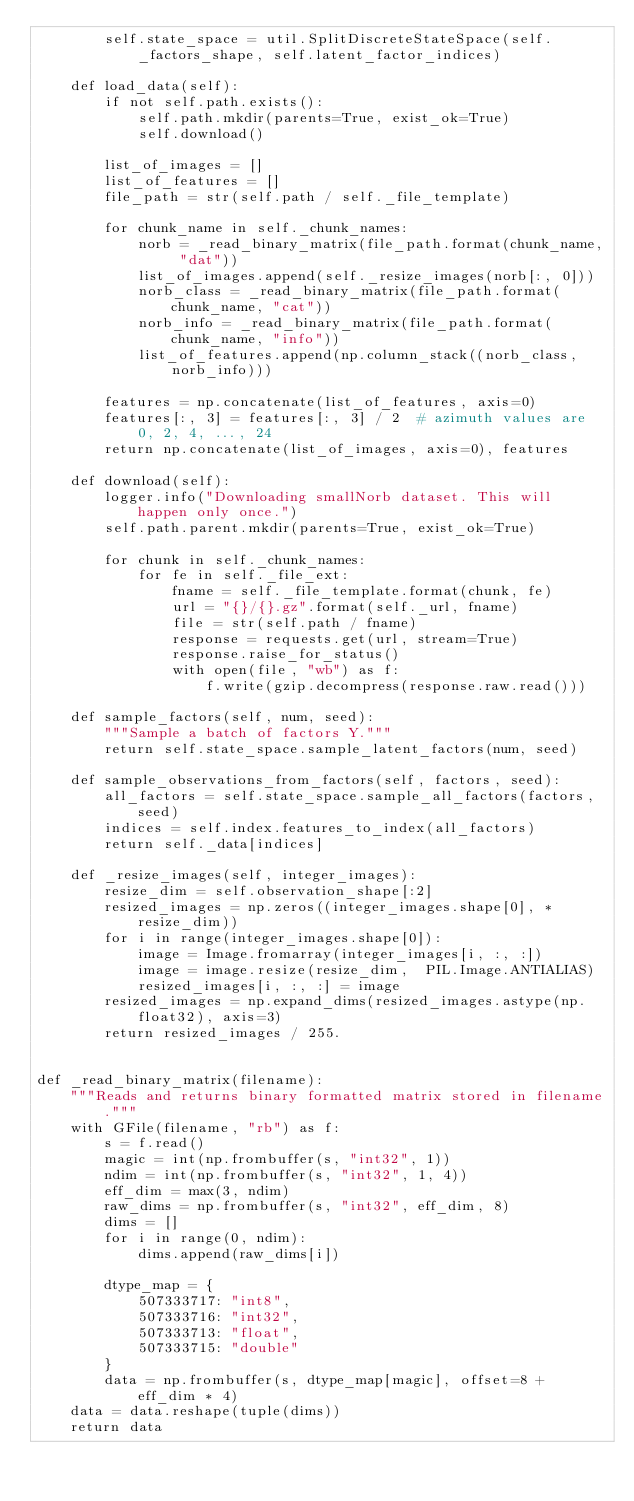<code> <loc_0><loc_0><loc_500><loc_500><_Python_>        self.state_space = util.SplitDiscreteStateSpace(self._factors_shape, self.latent_factor_indices)

    def load_data(self):
        if not self.path.exists():
            self.path.mkdir(parents=True, exist_ok=True)
            self.download()

        list_of_images = []
        list_of_features = []
        file_path = str(self.path / self._file_template)

        for chunk_name in self._chunk_names:
            norb = _read_binary_matrix(file_path.format(chunk_name, "dat"))
            list_of_images.append(self._resize_images(norb[:, 0]))
            norb_class = _read_binary_matrix(file_path.format(chunk_name, "cat"))
            norb_info = _read_binary_matrix(file_path.format(chunk_name, "info"))
            list_of_features.append(np.column_stack((norb_class, norb_info)))

        features = np.concatenate(list_of_features, axis=0)
        features[:, 3] = features[:, 3] / 2  # azimuth values are 0, 2, 4, ..., 24
        return np.concatenate(list_of_images, axis=0), features

    def download(self):
        logger.info("Downloading smallNorb dataset. This will happen only once.")
        self.path.parent.mkdir(parents=True, exist_ok=True)

        for chunk in self._chunk_names:
            for fe in self._file_ext:
                fname = self._file_template.format(chunk, fe)
                url = "{}/{}.gz".format(self._url, fname)
                file = str(self.path / fname)
                response = requests.get(url, stream=True)
                response.raise_for_status()
                with open(file, "wb") as f:
                    f.write(gzip.decompress(response.raw.read()))

    def sample_factors(self, num, seed):
        """Sample a batch of factors Y."""
        return self.state_space.sample_latent_factors(num, seed)

    def sample_observations_from_factors(self, factors, seed):
        all_factors = self.state_space.sample_all_factors(factors, seed)
        indices = self.index.features_to_index(all_factors)
        return self._data[indices]

    def _resize_images(self, integer_images):
        resize_dim = self.observation_shape[:2]
        resized_images = np.zeros((integer_images.shape[0], *resize_dim))
        for i in range(integer_images.shape[0]):
            image = Image.fromarray(integer_images[i, :, :])
            image = image.resize(resize_dim,  PIL.Image.ANTIALIAS)
            resized_images[i, :, :] = image
        resized_images = np.expand_dims(resized_images.astype(np.float32), axis=3)
        return resized_images / 255.


def _read_binary_matrix(filename):
    """Reads and returns binary formatted matrix stored in filename."""
    with GFile(filename, "rb") as f:
        s = f.read()
        magic = int(np.frombuffer(s, "int32", 1))
        ndim = int(np.frombuffer(s, "int32", 1, 4))
        eff_dim = max(3, ndim)
        raw_dims = np.frombuffer(s, "int32", eff_dim, 8)
        dims = []
        for i in range(0, ndim):
            dims.append(raw_dims[i])

        dtype_map = {
            507333717: "int8",
            507333716: "int32",
            507333713: "float",
            507333715: "double"
        }
        data = np.frombuffer(s, dtype_map[magic], offset=8 + eff_dim * 4)
    data = data.reshape(tuple(dims))
    return data



</code> 